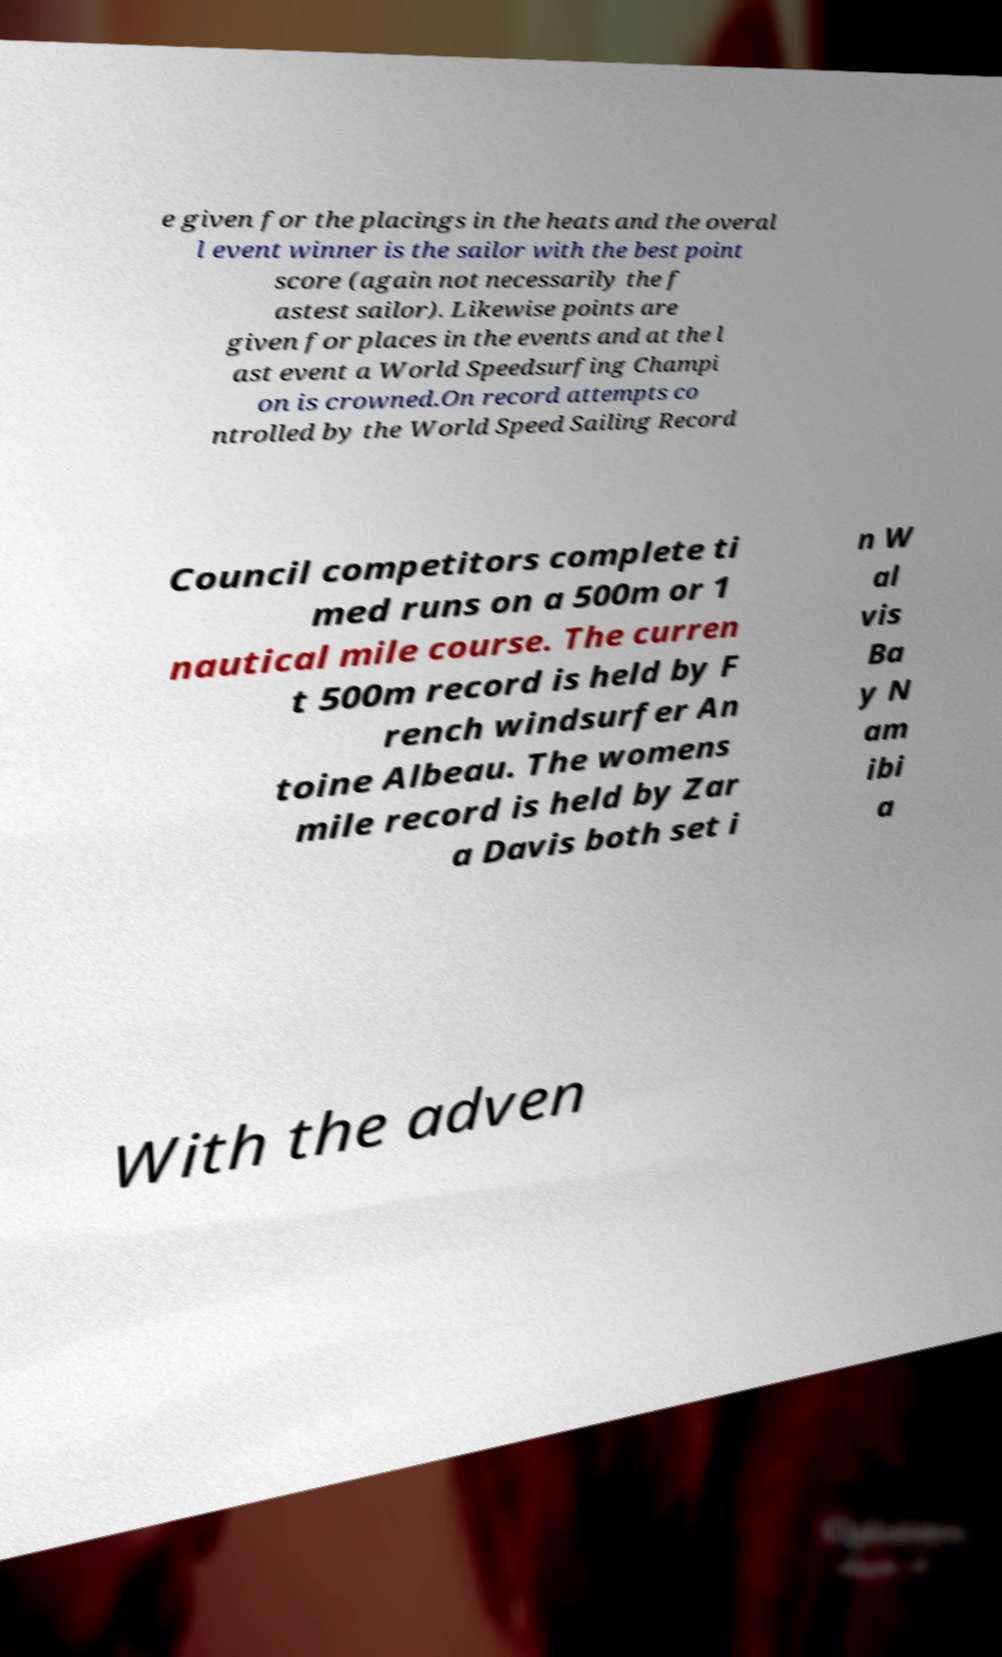Can you accurately transcribe the text from the provided image for me? e given for the placings in the heats and the overal l event winner is the sailor with the best point score (again not necessarily the f astest sailor). Likewise points are given for places in the events and at the l ast event a World Speedsurfing Champi on is crowned.On record attempts co ntrolled by the World Speed Sailing Record Council competitors complete ti med runs on a 500m or 1 nautical mile course. The curren t 500m record is held by F rench windsurfer An toine Albeau. The womens mile record is held by Zar a Davis both set i n W al vis Ba y N am ibi a With the adven 